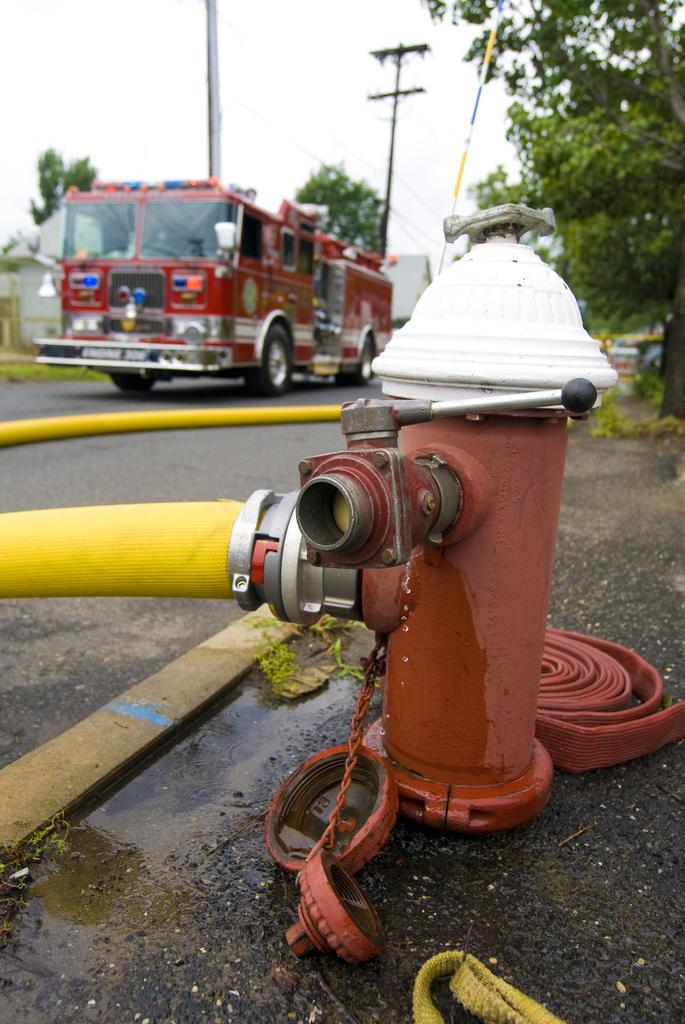What object is the main focus of the image? There is a fire hydrant in the image. What color is the pipe near the fire hydrant? The pipe is yellow. What type of vehicle can be seen in the background of the image? There is a bus in the background of the image. What type of infrastructure is visible in the background of the image? Electric wires and poles are visible in the background of the image. What type of natural element is present in the background of the image? Trees are present in the background of the image. What type of crayon is being used to color the curtain in the image? There is no crayon or curtain present in the image. 